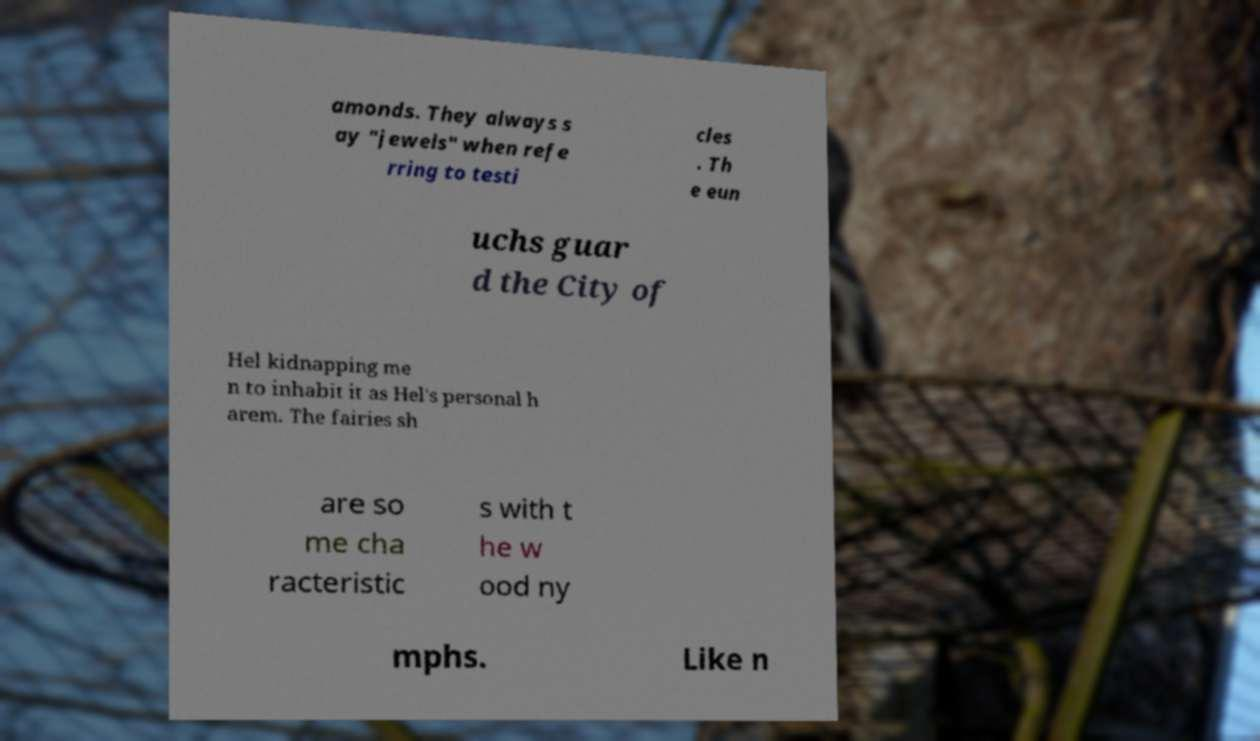I need the written content from this picture converted into text. Can you do that? amonds. They always s ay "jewels" when refe rring to testi cles . Th e eun uchs guar d the City of Hel kidnapping me n to inhabit it as Hel's personal h arem. The fairies sh are so me cha racteristic s with t he w ood ny mphs. Like n 